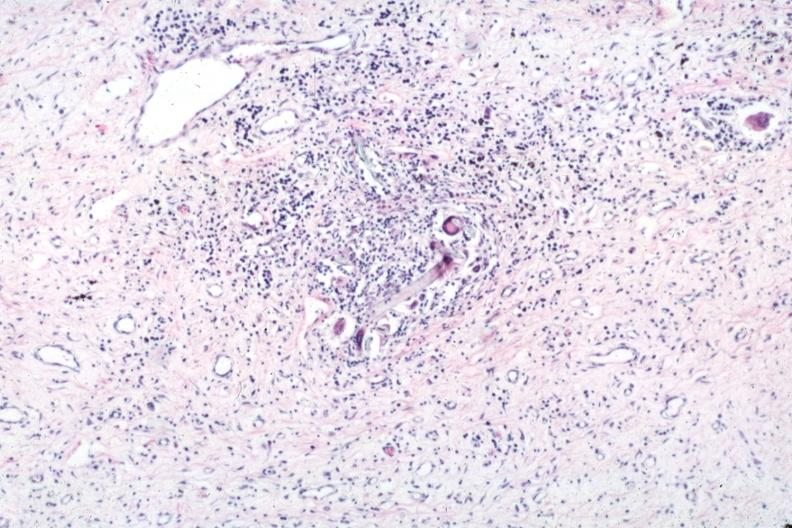does this image show typical lesion with giant cells and foreign material?
Answer the question using a single word or phrase. Yes 